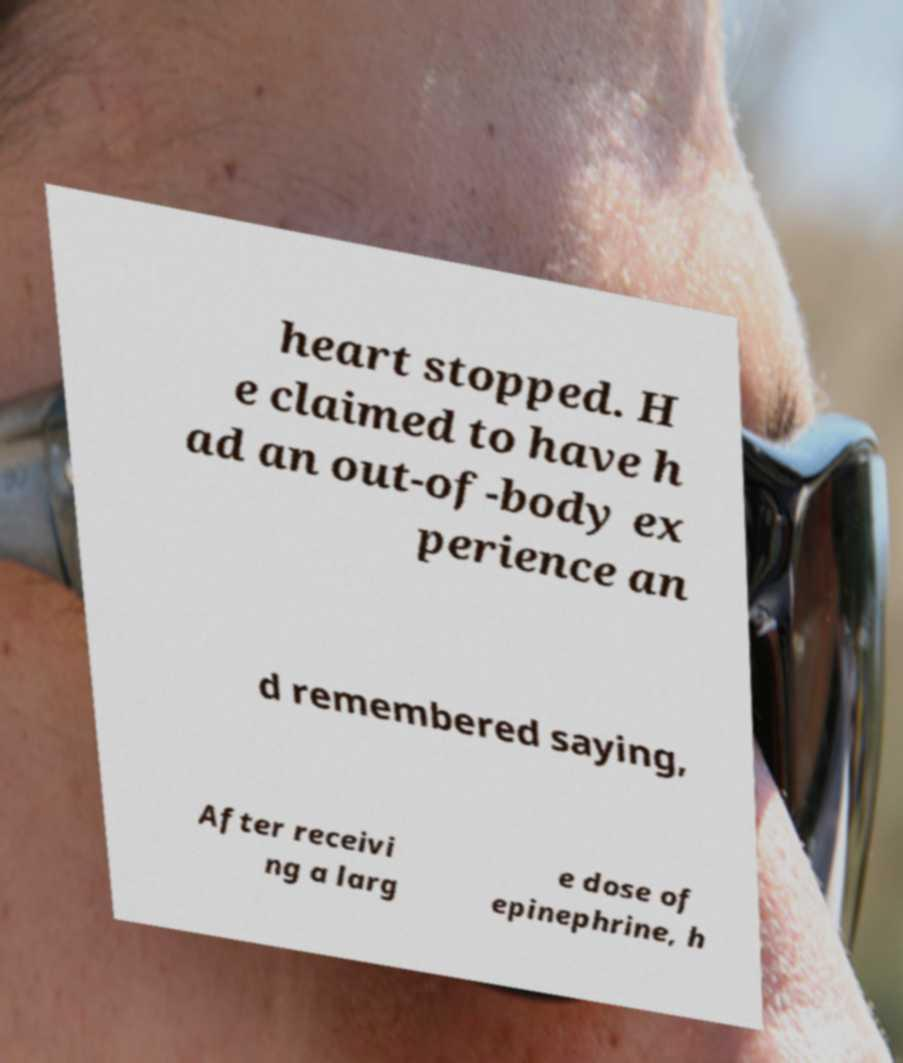Can you read and provide the text displayed in the image?This photo seems to have some interesting text. Can you extract and type it out for me? heart stopped. H e claimed to have h ad an out-of-body ex perience an d remembered saying, After receivi ng a larg e dose of epinephrine, h 